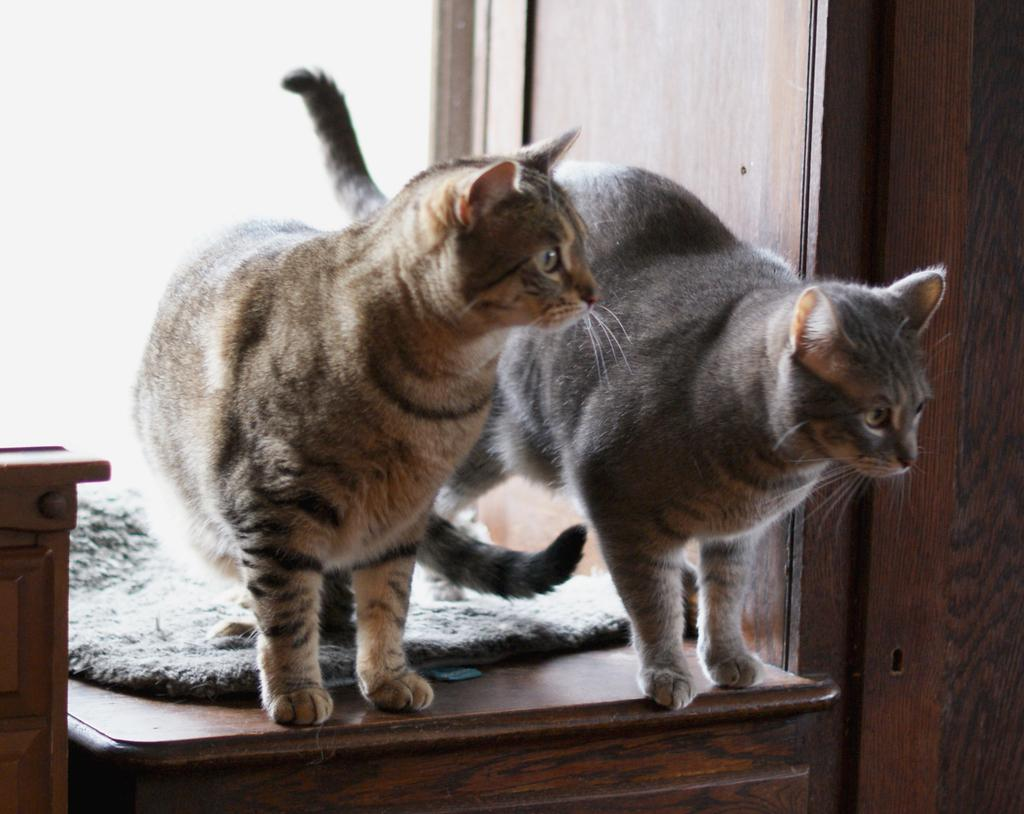How many cats can be seen in the image? There are two cats in the image. What are the cats sitting on? The cats are on a wooden object. What type of objects can be seen in the image? There are wooden objects visible in the image. Where is the wooden object located on the right side of the image? There is a wooden object on the right side of the image. Where is the wooden object located on the left side of the image? There is a wooden object on the left side of the image. What type of toothpaste is being used by the cats in the image? There is no toothpaste present in the image, and the cats are not using any toothpaste. 